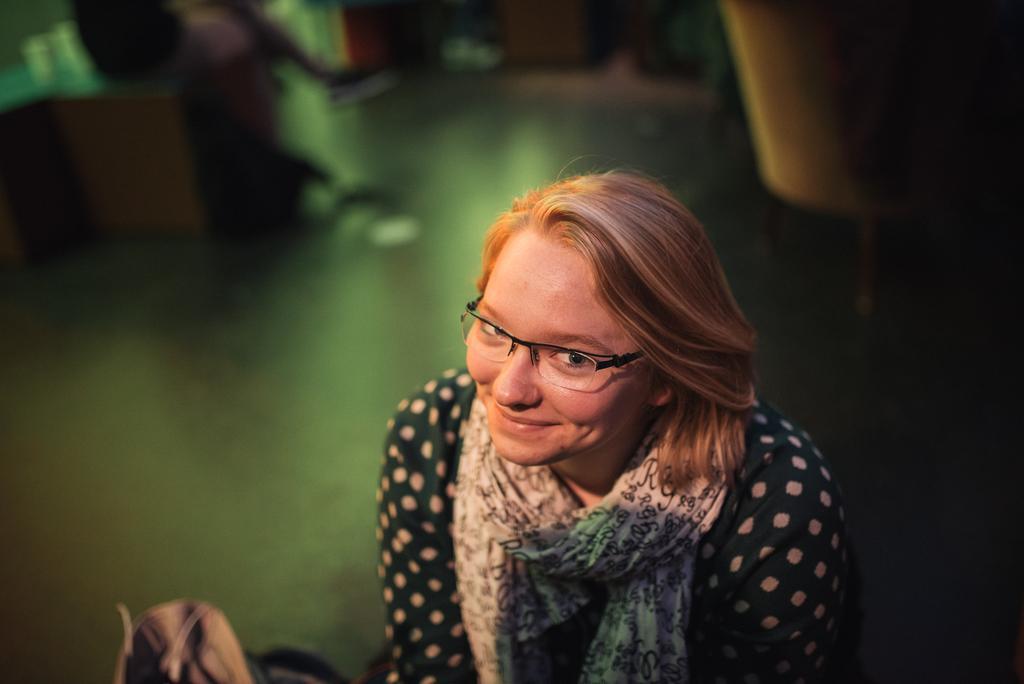Please provide a concise description of this image. In this image there is a woman with scarf and spectacles is smiling, and there is blur background. 